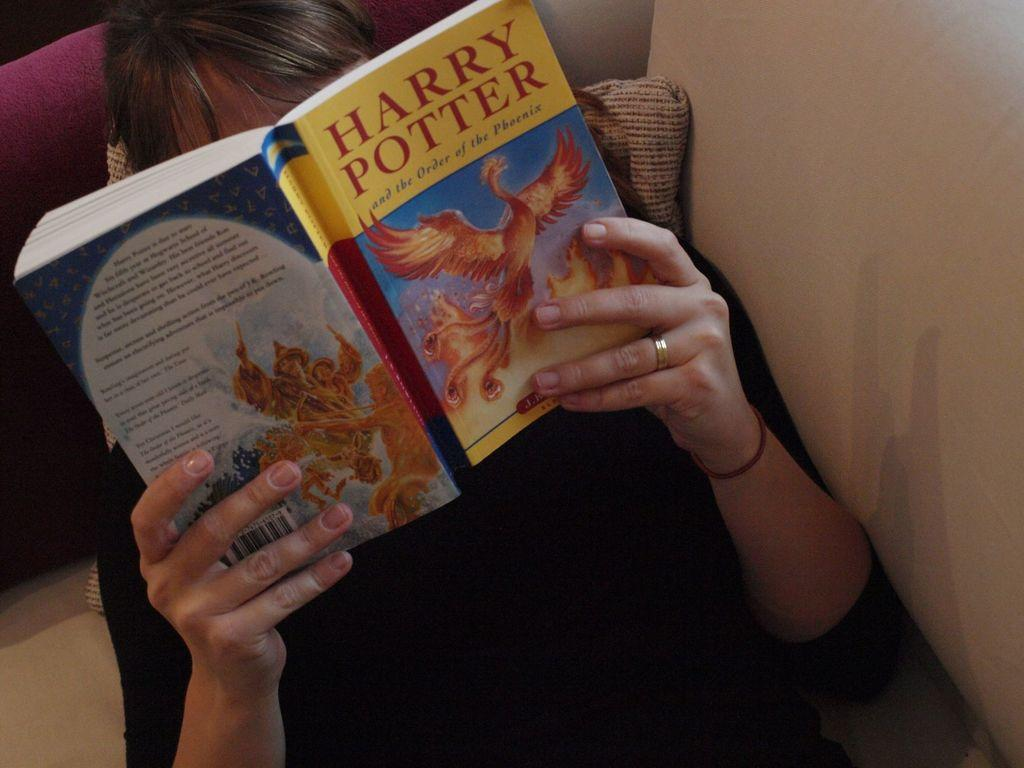<image>
Write a terse but informative summary of the picture. A person reading a paperback copy of Harry Potter and the Order of the Phoenix. 